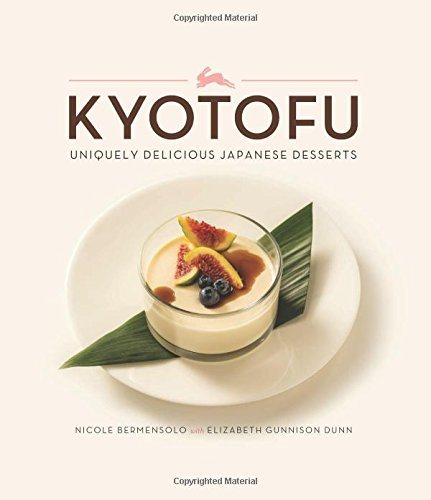What type of book is this? This is a cookbook within the 'Cookbooks, Food & Wine' category, focusing specifically on delectable and innovative Japanese desserts. 